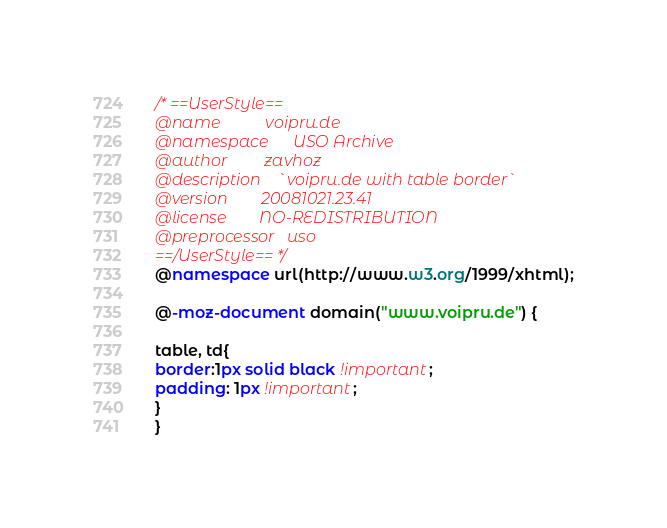Convert code to text. <code><loc_0><loc_0><loc_500><loc_500><_CSS_>/* ==UserStyle==
@name           voipru.de
@namespace      USO Archive
@author         zavhoz
@description    `voipru.de with table border`
@version        20081021.23.41
@license        NO-REDISTRIBUTION
@preprocessor   uso
==/UserStyle== */
@namespace url(http://www.w3.org/1999/xhtml);

@-moz-document domain("www.voipru.de") {

table, td{
border:1px solid black !important;
padding: 1px !important;
}
}</code> 